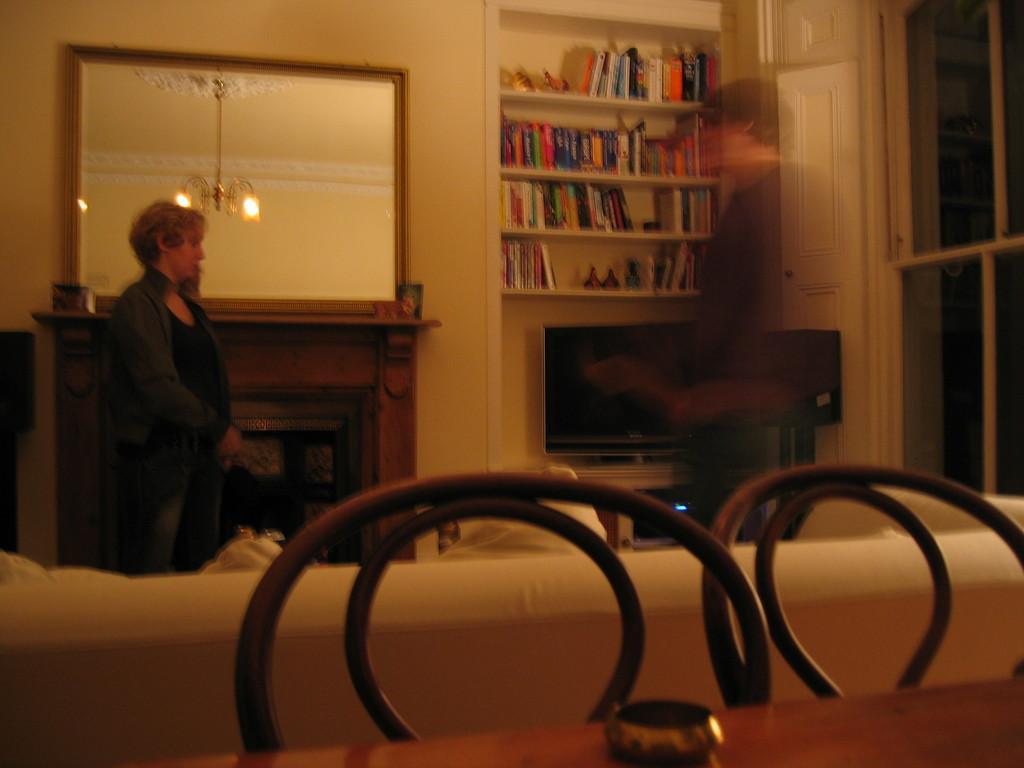Could you give a brief overview of what you see in this image? Here we can see a woman is standing, and at back here is the mirror, and here is the chandelier, and at here there is the books rack. 